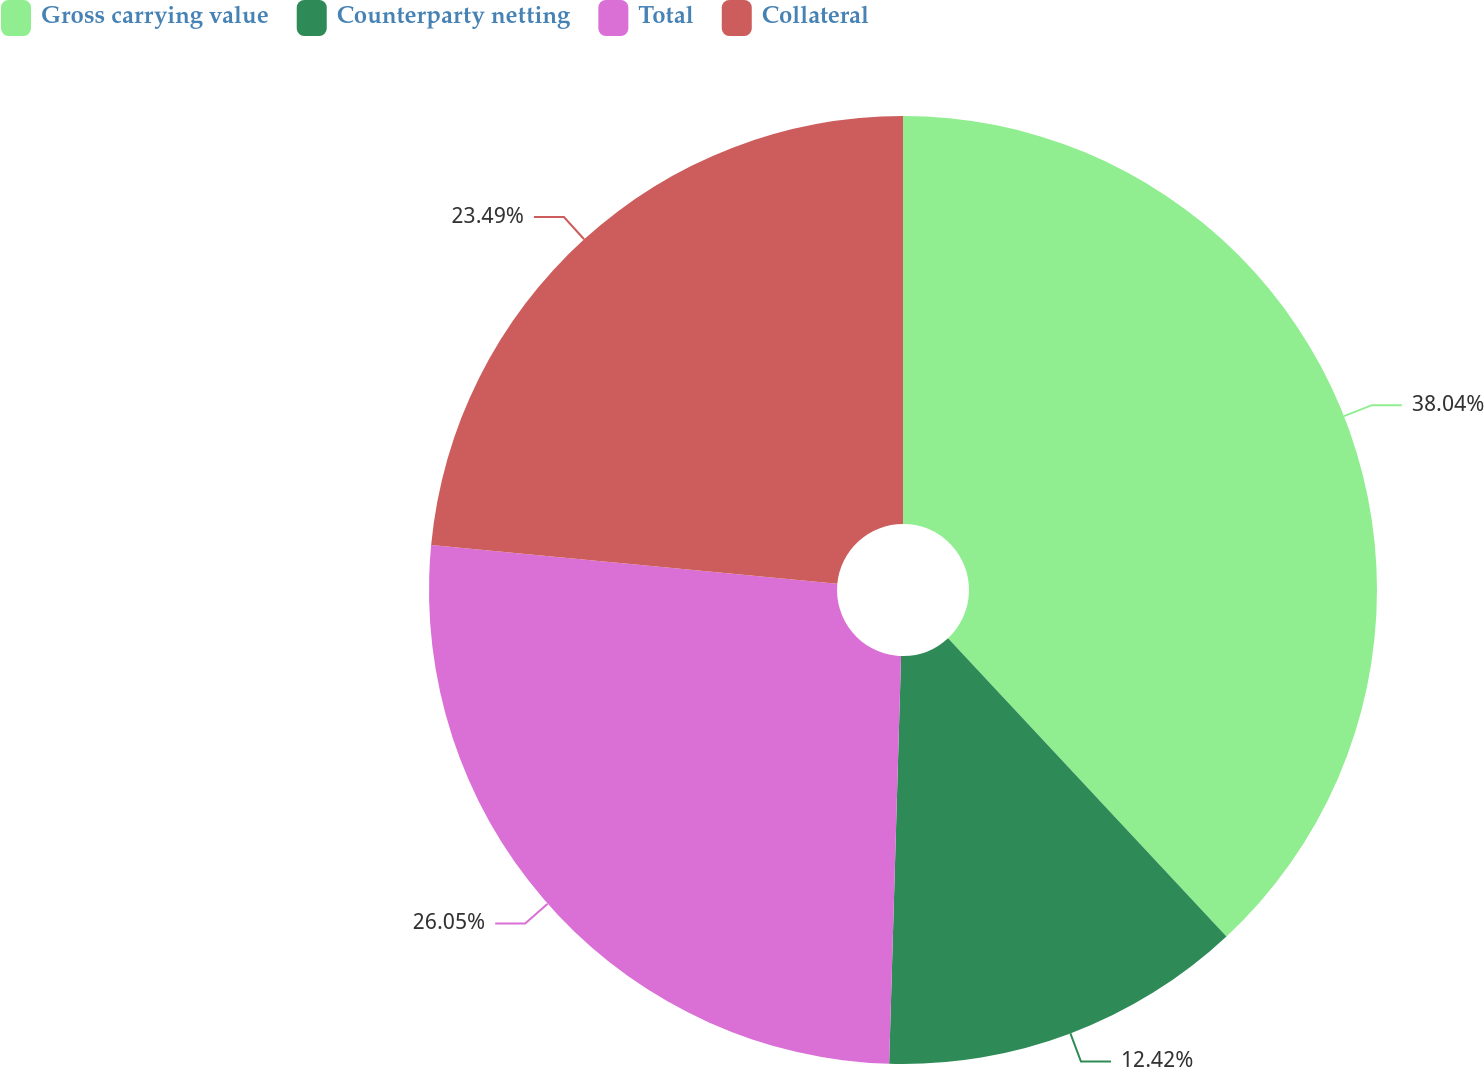<chart> <loc_0><loc_0><loc_500><loc_500><pie_chart><fcel>Gross carrying value<fcel>Counterparty netting<fcel>Total<fcel>Collateral<nl><fcel>38.05%<fcel>12.42%<fcel>26.05%<fcel>23.49%<nl></chart> 